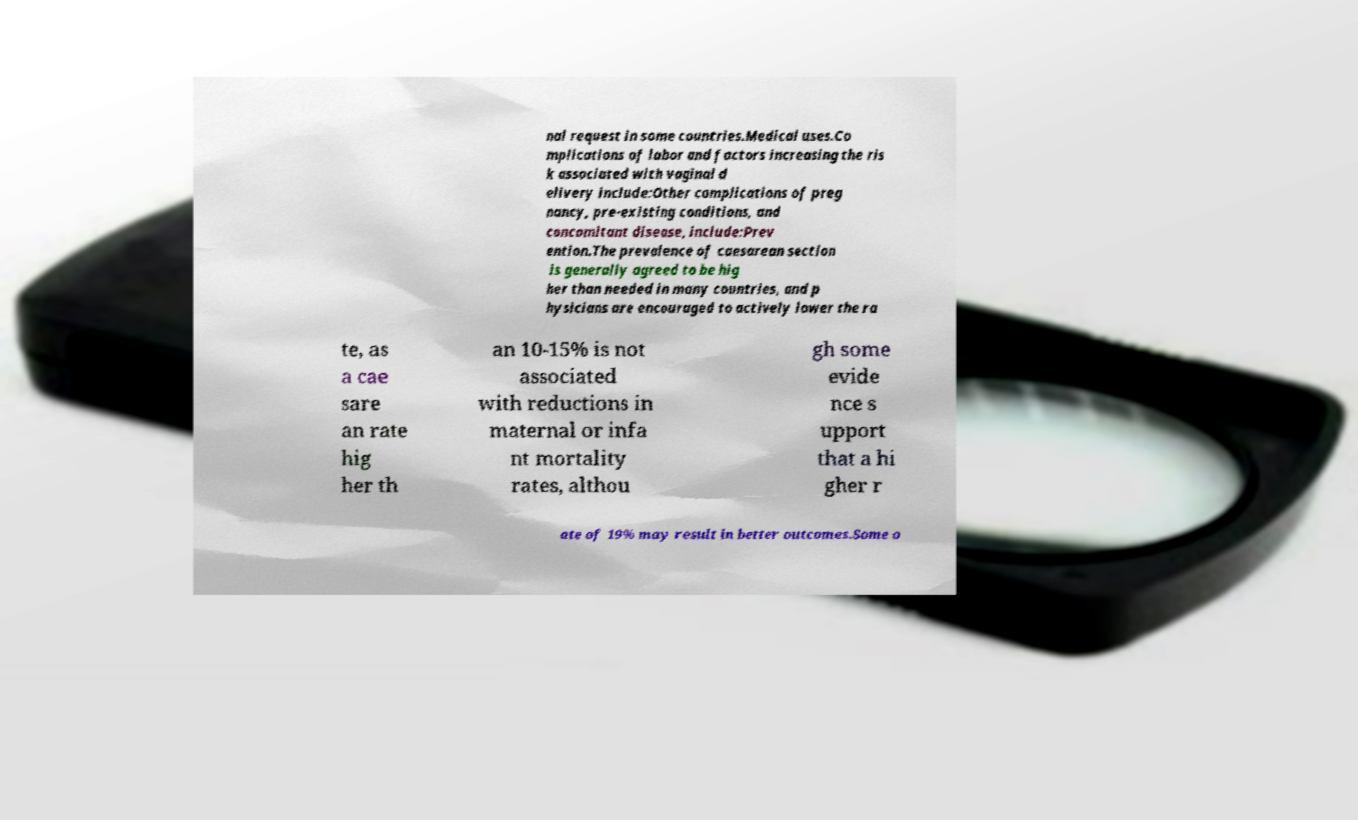Could you extract and type out the text from this image? nal request in some countries.Medical uses.Co mplications of labor and factors increasing the ris k associated with vaginal d elivery include:Other complications of preg nancy, pre-existing conditions, and concomitant disease, include:Prev ention.The prevalence of caesarean section is generally agreed to be hig her than needed in many countries, and p hysicians are encouraged to actively lower the ra te, as a cae sare an rate hig her th an 10-15% is not associated with reductions in maternal or infa nt mortality rates, althou gh some evide nce s upport that a hi gher r ate of 19% may result in better outcomes.Some o 